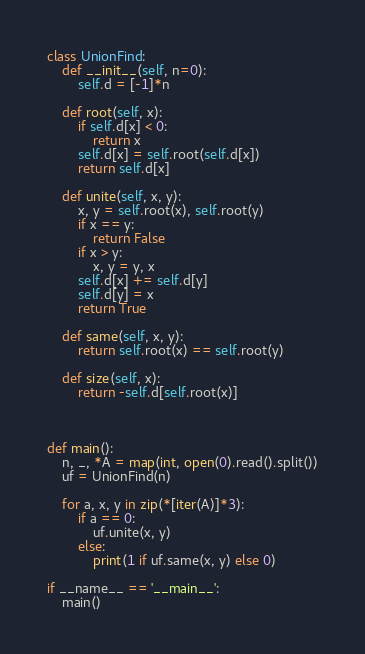<code> <loc_0><loc_0><loc_500><loc_500><_Python_>class UnionFind:
    def __init__(self, n=0):
        self.d = [-1]*n

    def root(self, x):
        if self.d[x] < 0:
            return x
        self.d[x] = self.root(self.d[x])
        return self.d[x]

    def unite(self, x, y):
        x, y = self.root(x), self.root(y)
        if x == y:
            return False
        if x > y:
            x, y = y, x
        self.d[x] += self.d[y]
        self.d[y] = x
        return True

    def same(self, x, y):
        return self.root(x) == self.root(y)

    def size(self, x):
        return -self.d[self.root(x)]



def main():
    n, _, *A = map(int, open(0).read().split())
    uf = UnionFind(n)

    for a, x, y in zip(*[iter(A)]*3):
        if a == 0:
            uf.unite(x, y)
        else:
            print(1 if uf.same(x, y) else 0)

if __name__ == '__main__':
    main()
</code> 